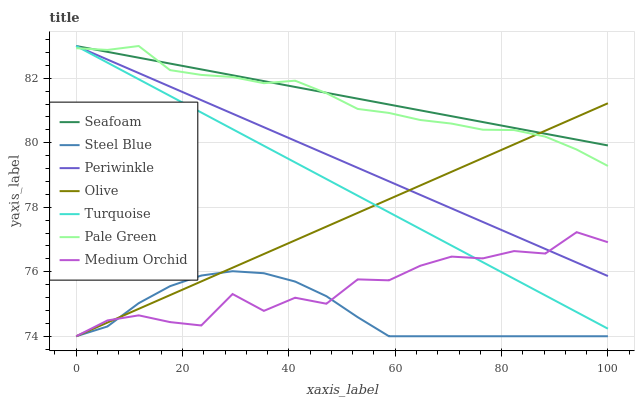Does Steel Blue have the minimum area under the curve?
Answer yes or no. Yes. Does Seafoam have the maximum area under the curve?
Answer yes or no. Yes. Does Medium Orchid have the minimum area under the curve?
Answer yes or no. No. Does Medium Orchid have the maximum area under the curve?
Answer yes or no. No. Is Turquoise the smoothest?
Answer yes or no. Yes. Is Medium Orchid the roughest?
Answer yes or no. Yes. Is Seafoam the smoothest?
Answer yes or no. No. Is Seafoam the roughest?
Answer yes or no. No. Does Medium Orchid have the lowest value?
Answer yes or no. Yes. Does Seafoam have the lowest value?
Answer yes or no. No. Does Periwinkle have the highest value?
Answer yes or no. Yes. Does Medium Orchid have the highest value?
Answer yes or no. No. Is Steel Blue less than Periwinkle?
Answer yes or no. Yes. Is Periwinkle greater than Steel Blue?
Answer yes or no. Yes. Does Periwinkle intersect Olive?
Answer yes or no. Yes. Is Periwinkle less than Olive?
Answer yes or no. No. Is Periwinkle greater than Olive?
Answer yes or no. No. Does Steel Blue intersect Periwinkle?
Answer yes or no. No. 